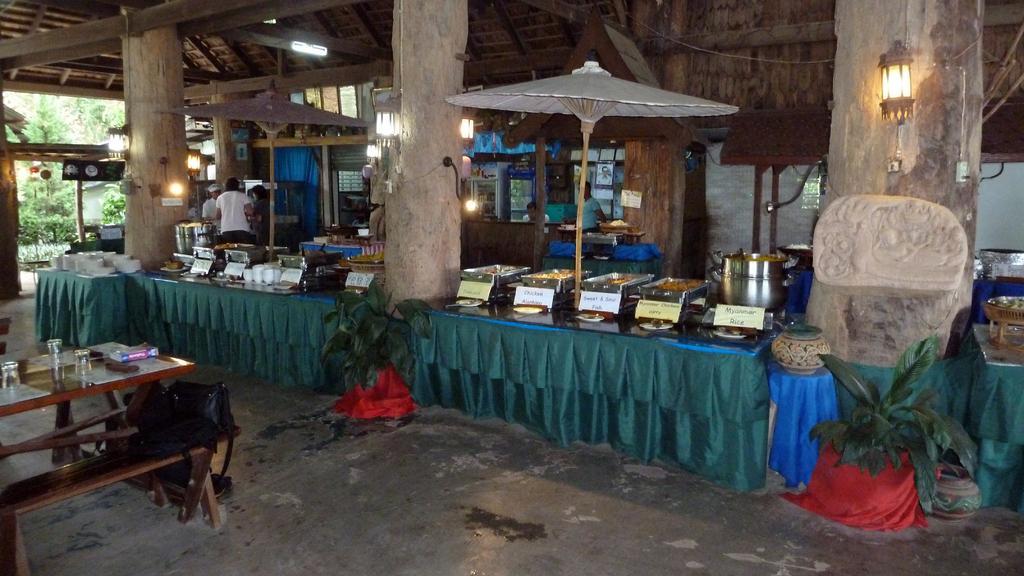How would you summarize this image in a sentence or two? There is a table. On the table there are some glasses and a book. And a bench is near the table. Bag are kept on the benches. there is a curtain. And two plants are kept on the pots. There are three pillars. And on the pillars lights are there. There are two umbrellas. Some food items are kept on the bowls. Some people are standing near the shops. In the background there are some trees. 